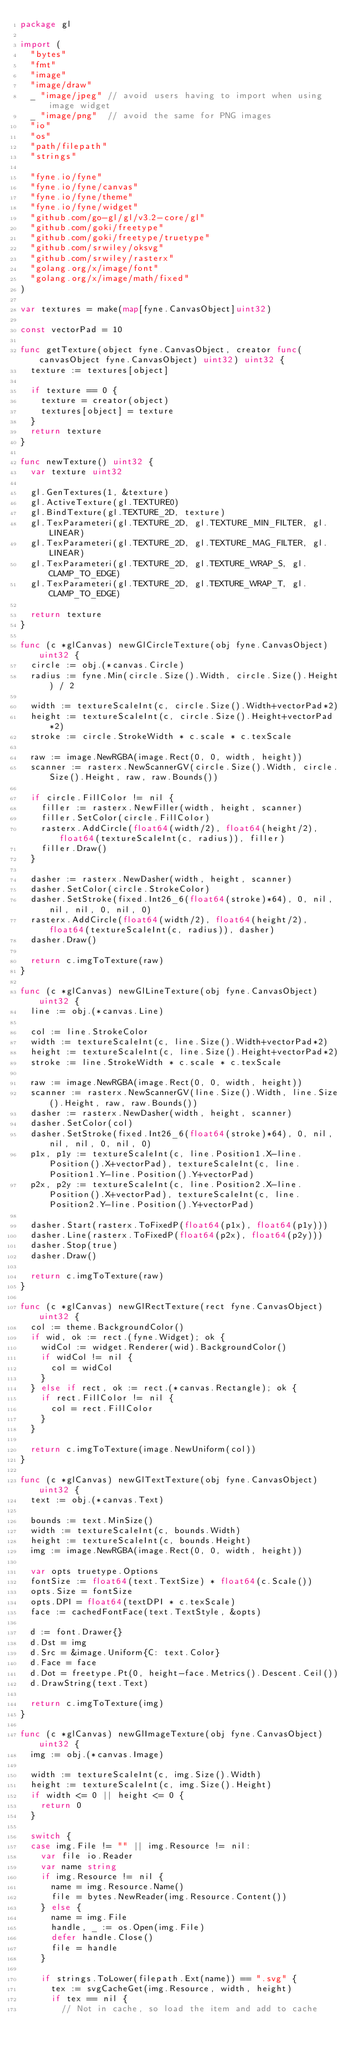<code> <loc_0><loc_0><loc_500><loc_500><_Go_>package gl

import (
	"bytes"
	"fmt"
	"image"
	"image/draw"
	_ "image/jpeg" // avoid users having to import when using image widget
	_ "image/png"  // avoid the same for PNG images
	"io"
	"os"
	"path/filepath"
	"strings"

	"fyne.io/fyne"
	"fyne.io/fyne/canvas"
	"fyne.io/fyne/theme"
	"fyne.io/fyne/widget"
	"github.com/go-gl/gl/v3.2-core/gl"
	"github.com/goki/freetype"
	"github.com/goki/freetype/truetype"
	"github.com/srwiley/oksvg"
	"github.com/srwiley/rasterx"
	"golang.org/x/image/font"
	"golang.org/x/image/math/fixed"
)

var textures = make(map[fyne.CanvasObject]uint32)

const vectorPad = 10

func getTexture(object fyne.CanvasObject, creator func(canvasObject fyne.CanvasObject) uint32) uint32 {
	texture := textures[object]

	if texture == 0 {
		texture = creator(object)
		textures[object] = texture
	}
	return texture
}

func newTexture() uint32 {
	var texture uint32

	gl.GenTextures(1, &texture)
	gl.ActiveTexture(gl.TEXTURE0)
	gl.BindTexture(gl.TEXTURE_2D, texture)
	gl.TexParameteri(gl.TEXTURE_2D, gl.TEXTURE_MIN_FILTER, gl.LINEAR)
	gl.TexParameteri(gl.TEXTURE_2D, gl.TEXTURE_MAG_FILTER, gl.LINEAR)
	gl.TexParameteri(gl.TEXTURE_2D, gl.TEXTURE_WRAP_S, gl.CLAMP_TO_EDGE)
	gl.TexParameteri(gl.TEXTURE_2D, gl.TEXTURE_WRAP_T, gl.CLAMP_TO_EDGE)

	return texture
}

func (c *glCanvas) newGlCircleTexture(obj fyne.CanvasObject) uint32 {
	circle := obj.(*canvas.Circle)
	radius := fyne.Min(circle.Size().Width, circle.Size().Height) / 2

	width := textureScaleInt(c, circle.Size().Width+vectorPad*2)
	height := textureScaleInt(c, circle.Size().Height+vectorPad*2)
	stroke := circle.StrokeWidth * c.scale * c.texScale

	raw := image.NewRGBA(image.Rect(0, 0, width, height))
	scanner := rasterx.NewScannerGV(circle.Size().Width, circle.Size().Height, raw, raw.Bounds())

	if circle.FillColor != nil {
		filler := rasterx.NewFiller(width, height, scanner)
		filler.SetColor(circle.FillColor)
		rasterx.AddCircle(float64(width/2), float64(height/2), float64(textureScaleInt(c, radius)), filler)
		filler.Draw()
	}

	dasher := rasterx.NewDasher(width, height, scanner)
	dasher.SetColor(circle.StrokeColor)
	dasher.SetStroke(fixed.Int26_6(float64(stroke)*64), 0, nil, nil, nil, 0, nil, 0)
	rasterx.AddCircle(float64(width/2), float64(height/2), float64(textureScaleInt(c, radius)), dasher)
	dasher.Draw()

	return c.imgToTexture(raw)
}

func (c *glCanvas) newGlLineTexture(obj fyne.CanvasObject) uint32 {
	line := obj.(*canvas.Line)

	col := line.StrokeColor
	width := textureScaleInt(c, line.Size().Width+vectorPad*2)
	height := textureScaleInt(c, line.Size().Height+vectorPad*2)
	stroke := line.StrokeWidth * c.scale * c.texScale

	raw := image.NewRGBA(image.Rect(0, 0, width, height))
	scanner := rasterx.NewScannerGV(line.Size().Width, line.Size().Height, raw, raw.Bounds())
	dasher := rasterx.NewDasher(width, height, scanner)
	dasher.SetColor(col)
	dasher.SetStroke(fixed.Int26_6(float64(stroke)*64), 0, nil, nil, nil, 0, nil, 0)
	p1x, p1y := textureScaleInt(c, line.Position1.X-line.Position().X+vectorPad), textureScaleInt(c, line.Position1.Y-line.Position().Y+vectorPad)
	p2x, p2y := textureScaleInt(c, line.Position2.X-line.Position().X+vectorPad), textureScaleInt(c, line.Position2.Y-line.Position().Y+vectorPad)

	dasher.Start(rasterx.ToFixedP(float64(p1x), float64(p1y)))
	dasher.Line(rasterx.ToFixedP(float64(p2x), float64(p2y)))
	dasher.Stop(true)
	dasher.Draw()

	return c.imgToTexture(raw)
}

func (c *glCanvas) newGlRectTexture(rect fyne.CanvasObject) uint32 {
	col := theme.BackgroundColor()
	if wid, ok := rect.(fyne.Widget); ok {
		widCol := widget.Renderer(wid).BackgroundColor()
		if widCol != nil {
			col = widCol
		}
	} else if rect, ok := rect.(*canvas.Rectangle); ok {
		if rect.FillColor != nil {
			col = rect.FillColor
		}
	}

	return c.imgToTexture(image.NewUniform(col))
}

func (c *glCanvas) newGlTextTexture(obj fyne.CanvasObject) uint32 {
	text := obj.(*canvas.Text)

	bounds := text.MinSize()
	width := textureScaleInt(c, bounds.Width)
	height := textureScaleInt(c, bounds.Height)
	img := image.NewRGBA(image.Rect(0, 0, width, height))

	var opts truetype.Options
	fontSize := float64(text.TextSize) * float64(c.Scale())
	opts.Size = fontSize
	opts.DPI = float64(textDPI * c.texScale)
	face := cachedFontFace(text.TextStyle, &opts)

	d := font.Drawer{}
	d.Dst = img
	d.Src = &image.Uniform{C: text.Color}
	d.Face = face
	d.Dot = freetype.Pt(0, height-face.Metrics().Descent.Ceil())
	d.DrawString(text.Text)

	return c.imgToTexture(img)
}

func (c *glCanvas) newGlImageTexture(obj fyne.CanvasObject) uint32 {
	img := obj.(*canvas.Image)

	width := textureScaleInt(c, img.Size().Width)
	height := textureScaleInt(c, img.Size().Height)
	if width <= 0 || height <= 0 {
		return 0
	}

	switch {
	case img.File != "" || img.Resource != nil:
		var file io.Reader
		var name string
		if img.Resource != nil {
			name = img.Resource.Name()
			file = bytes.NewReader(img.Resource.Content())
		} else {
			name = img.File
			handle, _ := os.Open(img.File)
			defer handle.Close()
			file = handle
		}

		if strings.ToLower(filepath.Ext(name)) == ".svg" {
			tex := svgCacheGet(img.Resource, width, height)
			if tex == nil {
				// Not in cache, so load the item and add to cache
</code> 